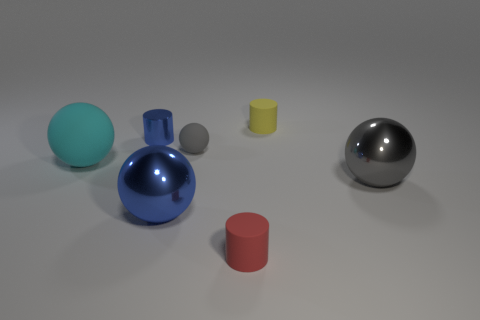There is a large metallic object right of the cylinder right of the red cylinder; what color is it?
Make the answer very short. Gray. Is the number of gray metallic objects that are behind the large cyan rubber sphere less than the number of blue things to the left of the blue sphere?
Provide a succinct answer. Yes. Is the size of the gray metal thing the same as the red rubber cylinder?
Offer a terse response. No. There is a large object that is on the left side of the yellow cylinder and on the right side of the large cyan matte thing; what is its shape?
Your answer should be very brief. Sphere. How many blue objects have the same material as the big gray ball?
Offer a very short reply. 2. There is a large ball in front of the large gray thing; how many spheres are to the left of it?
Provide a succinct answer. 1. What is the shape of the tiny object behind the small blue cylinder that is behind the small red thing that is in front of the large matte thing?
Offer a terse response. Cylinder. What size is the object that is the same color as the small rubber sphere?
Your response must be concise. Large. How many things are big green matte things or gray rubber spheres?
Your answer should be very brief. 1. What color is the metallic cylinder that is the same size as the gray matte sphere?
Your answer should be compact. Blue. 